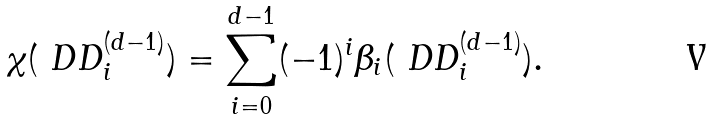<formula> <loc_0><loc_0><loc_500><loc_500>\chi ( { \ D D } _ { i } ^ { ( d - 1 ) } ) = \sum _ { i = 0 } ^ { d - 1 } ( - 1 ) ^ { i } \beta _ { i } ( { \ D D } _ { i } ^ { ( d - 1 ) } ) .</formula> 